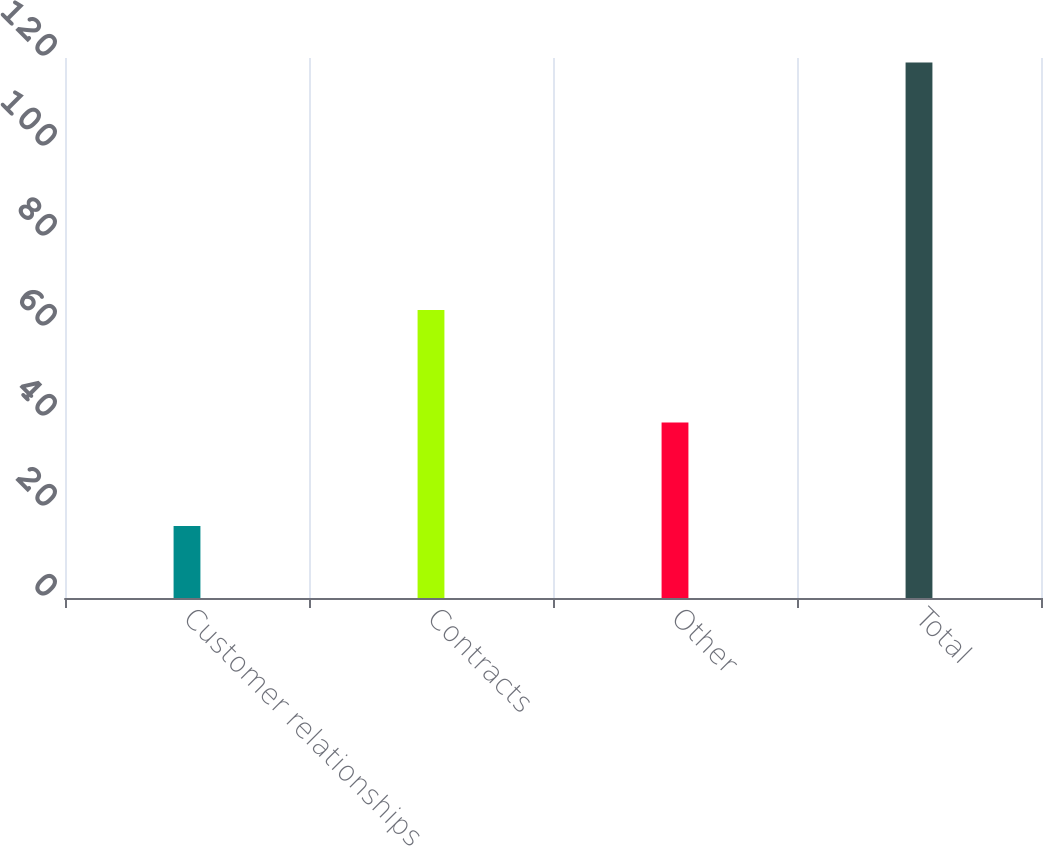<chart> <loc_0><loc_0><loc_500><loc_500><bar_chart><fcel>Customer relationships<fcel>Contracts<fcel>Other<fcel>Total<nl><fcel>16<fcel>64<fcel>39<fcel>119<nl></chart> 